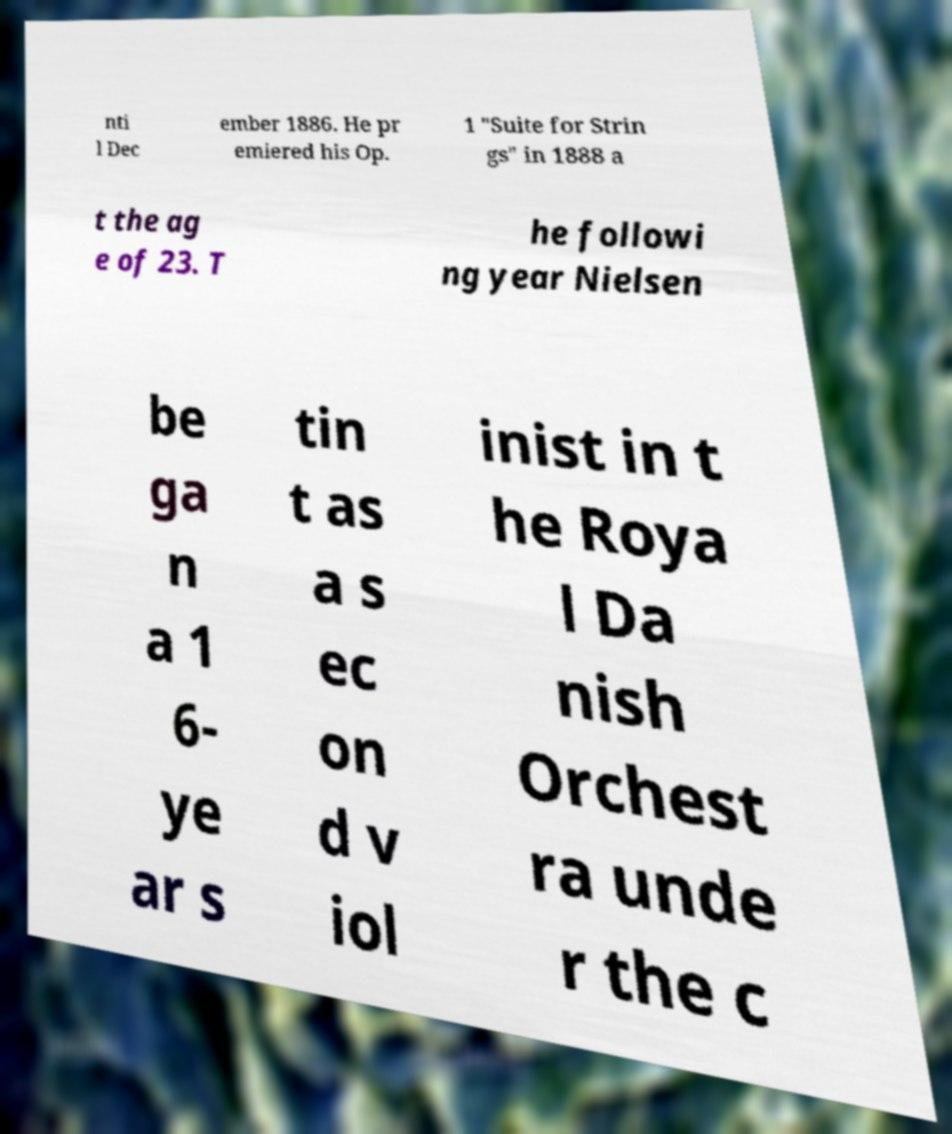For documentation purposes, I need the text within this image transcribed. Could you provide that? nti l Dec ember 1886. He pr emiered his Op. 1 "Suite for Strin gs" in 1888 a t the ag e of 23. T he followi ng year Nielsen be ga n a 1 6- ye ar s tin t as a s ec on d v iol inist in t he Roya l Da nish Orchest ra unde r the c 